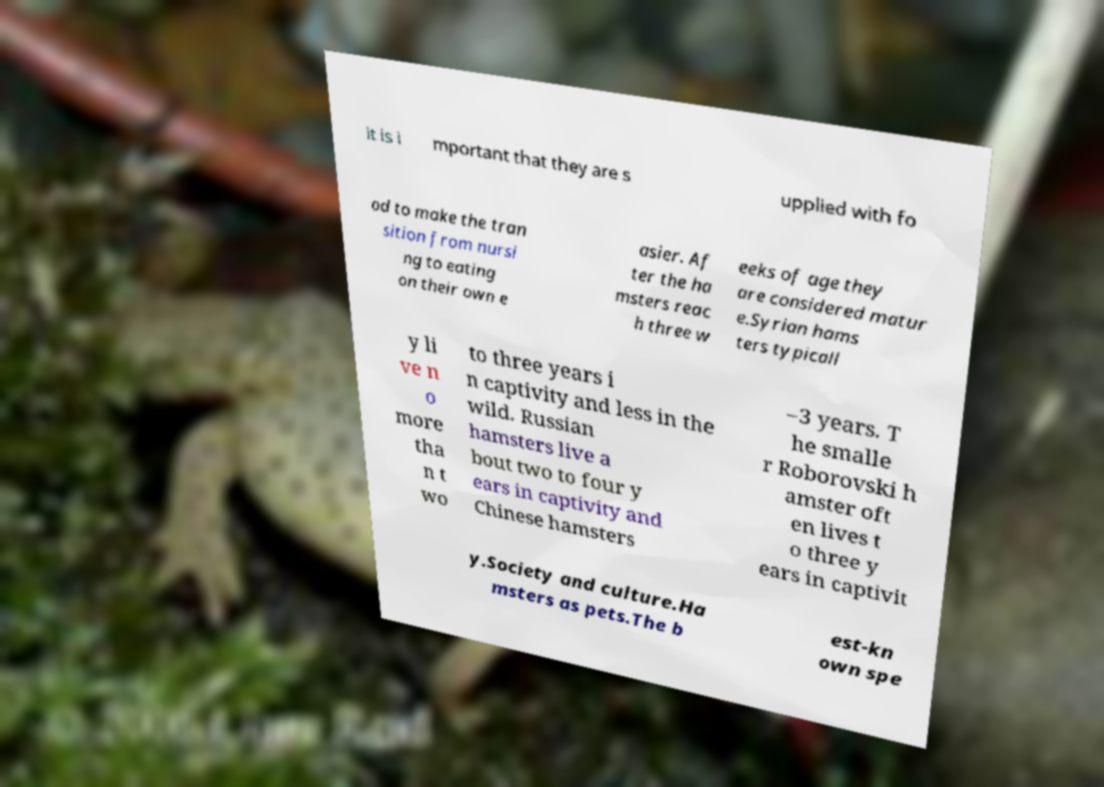What messages or text are displayed in this image? I need them in a readable, typed format. it is i mportant that they are s upplied with fo od to make the tran sition from nursi ng to eating on their own e asier. Af ter the ha msters reac h three w eeks of age they are considered matur e.Syrian hams ters typicall y li ve n o more tha n t wo to three years i n captivity and less in the wild. Russian hamsters live a bout two to four y ears in captivity and Chinese hamsters –3 years. T he smalle r Roborovski h amster oft en lives t o three y ears in captivit y.Society and culture.Ha msters as pets.The b est-kn own spe 